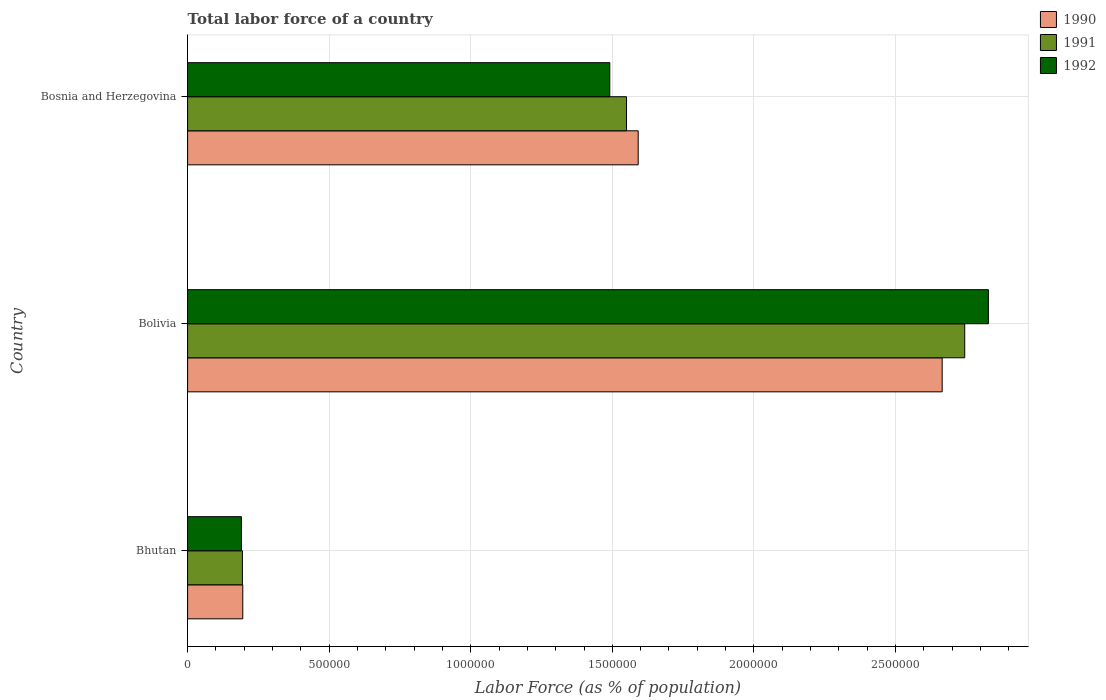Are the number of bars per tick equal to the number of legend labels?
Keep it short and to the point. Yes. Are the number of bars on each tick of the Y-axis equal?
Your answer should be very brief. Yes. What is the label of the 3rd group of bars from the top?
Offer a very short reply. Bhutan. In how many cases, is the number of bars for a given country not equal to the number of legend labels?
Your response must be concise. 0. What is the percentage of labor force in 1990 in Bolivia?
Your answer should be very brief. 2.66e+06. Across all countries, what is the maximum percentage of labor force in 1990?
Keep it short and to the point. 2.66e+06. Across all countries, what is the minimum percentage of labor force in 1990?
Your answer should be very brief. 1.95e+05. In which country was the percentage of labor force in 1991 minimum?
Your response must be concise. Bhutan. What is the total percentage of labor force in 1990 in the graph?
Give a very brief answer. 4.45e+06. What is the difference between the percentage of labor force in 1991 in Bolivia and that in Bosnia and Herzegovina?
Your answer should be compact. 1.19e+06. What is the difference between the percentage of labor force in 1990 in Bolivia and the percentage of labor force in 1991 in Bhutan?
Offer a very short reply. 2.47e+06. What is the average percentage of labor force in 1991 per country?
Ensure brevity in your answer.  1.50e+06. What is the difference between the percentage of labor force in 1991 and percentage of labor force in 1990 in Bolivia?
Make the answer very short. 7.96e+04. In how many countries, is the percentage of labor force in 1990 greater than 2300000 %?
Your answer should be compact. 1. What is the ratio of the percentage of labor force in 1992 in Bhutan to that in Bolivia?
Offer a terse response. 0.07. What is the difference between the highest and the second highest percentage of labor force in 1992?
Your response must be concise. 1.34e+06. What is the difference between the highest and the lowest percentage of labor force in 1992?
Give a very brief answer. 2.64e+06. What does the 2nd bar from the top in Bhutan represents?
Offer a terse response. 1991. What does the 3rd bar from the bottom in Bolivia represents?
Your answer should be very brief. 1992. Is it the case that in every country, the sum of the percentage of labor force in 1992 and percentage of labor force in 1991 is greater than the percentage of labor force in 1990?
Provide a succinct answer. Yes. Are all the bars in the graph horizontal?
Give a very brief answer. Yes. Does the graph contain any zero values?
Offer a very short reply. No. Does the graph contain grids?
Provide a succinct answer. Yes. How many legend labels are there?
Provide a succinct answer. 3. How are the legend labels stacked?
Provide a succinct answer. Vertical. What is the title of the graph?
Provide a short and direct response. Total labor force of a country. What is the label or title of the X-axis?
Make the answer very short. Labor Force (as % of population). What is the Labor Force (as % of population) in 1990 in Bhutan?
Your answer should be compact. 1.95e+05. What is the Labor Force (as % of population) of 1991 in Bhutan?
Offer a terse response. 1.94e+05. What is the Labor Force (as % of population) of 1992 in Bhutan?
Offer a very short reply. 1.90e+05. What is the Labor Force (as % of population) in 1990 in Bolivia?
Provide a succinct answer. 2.66e+06. What is the Labor Force (as % of population) in 1991 in Bolivia?
Give a very brief answer. 2.74e+06. What is the Labor Force (as % of population) of 1992 in Bolivia?
Provide a succinct answer. 2.83e+06. What is the Labor Force (as % of population) of 1990 in Bosnia and Herzegovina?
Offer a very short reply. 1.59e+06. What is the Labor Force (as % of population) of 1991 in Bosnia and Herzegovina?
Your answer should be very brief. 1.55e+06. What is the Labor Force (as % of population) in 1992 in Bosnia and Herzegovina?
Make the answer very short. 1.49e+06. Across all countries, what is the maximum Labor Force (as % of population) in 1990?
Provide a succinct answer. 2.66e+06. Across all countries, what is the maximum Labor Force (as % of population) in 1991?
Ensure brevity in your answer.  2.74e+06. Across all countries, what is the maximum Labor Force (as % of population) of 1992?
Ensure brevity in your answer.  2.83e+06. Across all countries, what is the minimum Labor Force (as % of population) of 1990?
Your response must be concise. 1.95e+05. Across all countries, what is the minimum Labor Force (as % of population) in 1991?
Offer a very short reply. 1.94e+05. Across all countries, what is the minimum Labor Force (as % of population) of 1992?
Your answer should be very brief. 1.90e+05. What is the total Labor Force (as % of population) in 1990 in the graph?
Provide a succinct answer. 4.45e+06. What is the total Labor Force (as % of population) in 1991 in the graph?
Provide a succinct answer. 4.49e+06. What is the total Labor Force (as % of population) of 1992 in the graph?
Your answer should be very brief. 4.51e+06. What is the difference between the Labor Force (as % of population) of 1990 in Bhutan and that in Bolivia?
Offer a terse response. -2.47e+06. What is the difference between the Labor Force (as % of population) of 1991 in Bhutan and that in Bolivia?
Ensure brevity in your answer.  -2.55e+06. What is the difference between the Labor Force (as % of population) of 1992 in Bhutan and that in Bolivia?
Give a very brief answer. -2.64e+06. What is the difference between the Labor Force (as % of population) of 1990 in Bhutan and that in Bosnia and Herzegovina?
Your answer should be compact. -1.40e+06. What is the difference between the Labor Force (as % of population) in 1991 in Bhutan and that in Bosnia and Herzegovina?
Your response must be concise. -1.36e+06. What is the difference between the Labor Force (as % of population) of 1992 in Bhutan and that in Bosnia and Herzegovina?
Your answer should be compact. -1.30e+06. What is the difference between the Labor Force (as % of population) of 1990 in Bolivia and that in Bosnia and Herzegovina?
Your answer should be compact. 1.07e+06. What is the difference between the Labor Force (as % of population) of 1991 in Bolivia and that in Bosnia and Herzegovina?
Offer a terse response. 1.19e+06. What is the difference between the Labor Force (as % of population) in 1992 in Bolivia and that in Bosnia and Herzegovina?
Make the answer very short. 1.34e+06. What is the difference between the Labor Force (as % of population) of 1990 in Bhutan and the Labor Force (as % of population) of 1991 in Bolivia?
Your answer should be very brief. -2.55e+06. What is the difference between the Labor Force (as % of population) of 1990 in Bhutan and the Labor Force (as % of population) of 1992 in Bolivia?
Your answer should be compact. -2.63e+06. What is the difference between the Labor Force (as % of population) in 1991 in Bhutan and the Labor Force (as % of population) in 1992 in Bolivia?
Provide a short and direct response. -2.63e+06. What is the difference between the Labor Force (as % of population) of 1990 in Bhutan and the Labor Force (as % of population) of 1991 in Bosnia and Herzegovina?
Provide a succinct answer. -1.36e+06. What is the difference between the Labor Force (as % of population) of 1990 in Bhutan and the Labor Force (as % of population) of 1992 in Bosnia and Herzegovina?
Your answer should be very brief. -1.30e+06. What is the difference between the Labor Force (as % of population) in 1991 in Bhutan and the Labor Force (as % of population) in 1992 in Bosnia and Herzegovina?
Your response must be concise. -1.30e+06. What is the difference between the Labor Force (as % of population) of 1990 in Bolivia and the Labor Force (as % of population) of 1991 in Bosnia and Herzegovina?
Your answer should be very brief. 1.11e+06. What is the difference between the Labor Force (as % of population) of 1990 in Bolivia and the Labor Force (as % of population) of 1992 in Bosnia and Herzegovina?
Provide a short and direct response. 1.17e+06. What is the difference between the Labor Force (as % of population) in 1991 in Bolivia and the Labor Force (as % of population) in 1992 in Bosnia and Herzegovina?
Offer a very short reply. 1.25e+06. What is the average Labor Force (as % of population) in 1990 per country?
Your answer should be very brief. 1.48e+06. What is the average Labor Force (as % of population) in 1991 per country?
Your answer should be compact. 1.50e+06. What is the average Labor Force (as % of population) of 1992 per country?
Offer a very short reply. 1.50e+06. What is the difference between the Labor Force (as % of population) in 1990 and Labor Force (as % of population) in 1991 in Bhutan?
Your response must be concise. 1316. What is the difference between the Labor Force (as % of population) in 1990 and Labor Force (as % of population) in 1992 in Bhutan?
Your answer should be very brief. 4812. What is the difference between the Labor Force (as % of population) of 1991 and Labor Force (as % of population) of 1992 in Bhutan?
Keep it short and to the point. 3496. What is the difference between the Labor Force (as % of population) in 1990 and Labor Force (as % of population) in 1991 in Bolivia?
Give a very brief answer. -7.96e+04. What is the difference between the Labor Force (as % of population) of 1990 and Labor Force (as % of population) of 1992 in Bolivia?
Your response must be concise. -1.63e+05. What is the difference between the Labor Force (as % of population) in 1991 and Labor Force (as % of population) in 1992 in Bolivia?
Your response must be concise. -8.36e+04. What is the difference between the Labor Force (as % of population) in 1990 and Labor Force (as % of population) in 1991 in Bosnia and Herzegovina?
Give a very brief answer. 4.12e+04. What is the difference between the Labor Force (as % of population) in 1990 and Labor Force (as % of population) in 1992 in Bosnia and Herzegovina?
Offer a terse response. 1.00e+05. What is the difference between the Labor Force (as % of population) of 1991 and Labor Force (as % of population) of 1992 in Bosnia and Herzegovina?
Ensure brevity in your answer.  5.91e+04. What is the ratio of the Labor Force (as % of population) of 1990 in Bhutan to that in Bolivia?
Give a very brief answer. 0.07. What is the ratio of the Labor Force (as % of population) of 1991 in Bhutan to that in Bolivia?
Offer a very short reply. 0.07. What is the ratio of the Labor Force (as % of population) in 1992 in Bhutan to that in Bolivia?
Your answer should be compact. 0.07. What is the ratio of the Labor Force (as % of population) in 1990 in Bhutan to that in Bosnia and Herzegovina?
Offer a terse response. 0.12. What is the ratio of the Labor Force (as % of population) in 1991 in Bhutan to that in Bosnia and Herzegovina?
Provide a short and direct response. 0.12. What is the ratio of the Labor Force (as % of population) of 1992 in Bhutan to that in Bosnia and Herzegovina?
Ensure brevity in your answer.  0.13. What is the ratio of the Labor Force (as % of population) of 1990 in Bolivia to that in Bosnia and Herzegovina?
Offer a terse response. 1.67. What is the ratio of the Labor Force (as % of population) in 1991 in Bolivia to that in Bosnia and Herzegovina?
Offer a terse response. 1.77. What is the ratio of the Labor Force (as % of population) in 1992 in Bolivia to that in Bosnia and Herzegovina?
Make the answer very short. 1.9. What is the difference between the highest and the second highest Labor Force (as % of population) of 1990?
Your answer should be very brief. 1.07e+06. What is the difference between the highest and the second highest Labor Force (as % of population) in 1991?
Offer a very short reply. 1.19e+06. What is the difference between the highest and the second highest Labor Force (as % of population) in 1992?
Your response must be concise. 1.34e+06. What is the difference between the highest and the lowest Labor Force (as % of population) of 1990?
Offer a very short reply. 2.47e+06. What is the difference between the highest and the lowest Labor Force (as % of population) of 1991?
Your response must be concise. 2.55e+06. What is the difference between the highest and the lowest Labor Force (as % of population) of 1992?
Your answer should be compact. 2.64e+06. 